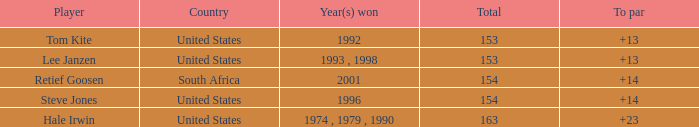In what year did the United States win To par greater than 14 1974 , 1979 , 1990. 